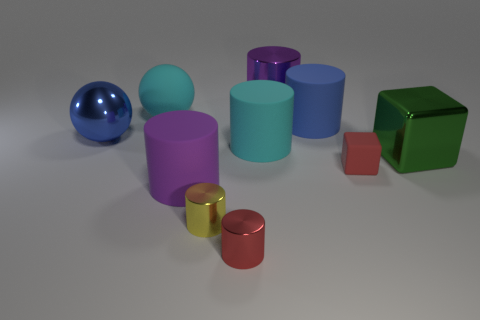What number of other objects are there of the same material as the cyan sphere?
Provide a succinct answer. 4. The big shiny thing that is left of the cyan sphere is what color?
Ensure brevity in your answer.  Blue. What material is the large purple thing that is in front of the purple thing behind the red matte cube in front of the big cyan sphere?
Keep it short and to the point. Rubber. Are there any large purple matte objects of the same shape as the small yellow object?
Your answer should be compact. Yes. What is the shape of the red thing that is the same size as the red cylinder?
Your answer should be very brief. Cube. How many large metallic things are on the left side of the small yellow metallic cylinder and right of the large blue cylinder?
Offer a terse response. 0. Are there fewer red shiny things to the left of the big cyan matte sphere than rubber cylinders?
Offer a terse response. Yes. Is there a purple object of the same size as the red rubber object?
Ensure brevity in your answer.  No. What color is the sphere that is made of the same material as the blue cylinder?
Keep it short and to the point. Cyan. What number of large objects are on the left side of the large cyan thing on the left side of the big cyan cylinder?
Make the answer very short. 1. 